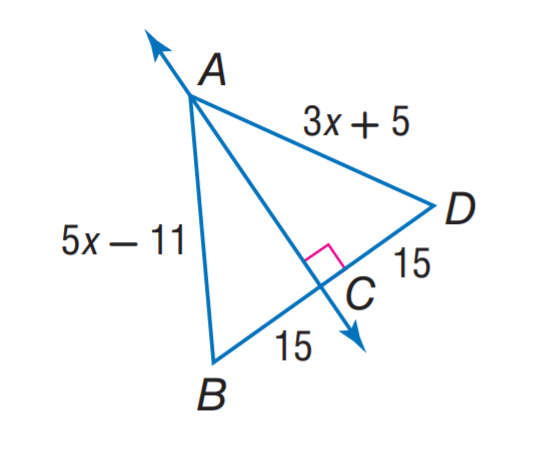Question: Find A B.
Choices:
A. 11
B. 15
C. 26
D. 29
Answer with the letter. Answer: D 